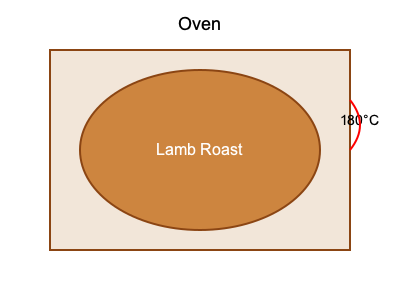For your traditional Greek Easter celebration abroad, you're preparing a lamb roast. The recipe states that you should cook the lamb for 25 minutes per 500 grams, plus an additional 25 minutes. If your lamb roast weighs 2.75 kg and is roughly spherical in shape, how long should you cook it in the oven at 180°C? To calculate the cooking time for the lamb roast, we'll follow these steps:

1. Convert the weight from kg to grams:
   $2.75 \text{ kg} = 2750 \text{ g}$

2. Calculate the number of 500g portions:
   $\frac{2750 \text{ g}}{500 \text{ g}} = 5.5 \text{ portions}$

3. Calculate the cooking time for the weight:
   $5.5 \times 25 \text{ minutes} = 137.5 \text{ minutes}$

4. Add the additional 25 minutes:
   $137.5 \text{ minutes} + 25 \text{ minutes} = 162.5 \text{ minutes}$

5. Convert the total time to hours and minutes:
   $162.5 \text{ minutes} = 2 \text{ hours and } 42.5 \text{ minutes}$

Therefore, you should cook the lamb roast for 2 hours and 43 minutes (rounding up to the nearest minute) at 180°C.

Note: The spherical shape of the roast ensures even heat distribution, so no additional time adjustments are necessary.
Answer: 2 hours and 43 minutes 